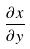<formula> <loc_0><loc_0><loc_500><loc_500>\frac { \partial x } { \partial y }</formula> 